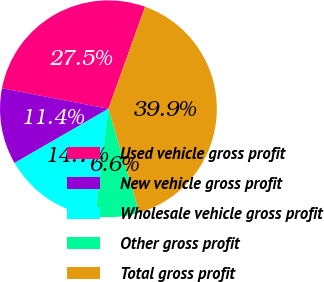Convert chart to OTSL. <chart><loc_0><loc_0><loc_500><loc_500><pie_chart><fcel>Used vehicle gross profit<fcel>New vehicle gross profit<fcel>Wholesale vehicle gross profit<fcel>Other gross profit<fcel>Total gross profit<nl><fcel>27.46%<fcel>11.37%<fcel>14.71%<fcel>6.56%<fcel>39.9%<nl></chart> 